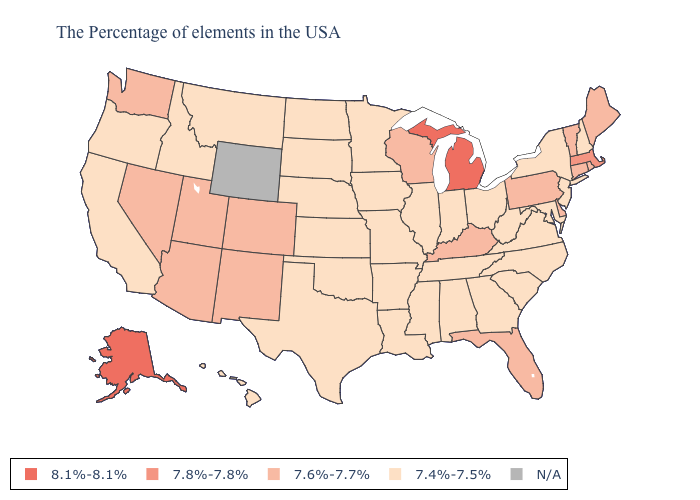Does Michigan have the highest value in the MidWest?
Give a very brief answer. Yes. What is the highest value in the USA?
Give a very brief answer. 8.1%-8.1%. Name the states that have a value in the range 8.1%-8.1%?
Concise answer only. Michigan, Alaska. Does California have the highest value in the USA?
Give a very brief answer. No. Name the states that have a value in the range 7.6%-7.7%?
Keep it brief. Maine, Rhode Island, Vermont, Connecticut, Delaware, Pennsylvania, Florida, Kentucky, Wisconsin, Colorado, New Mexico, Utah, Arizona, Nevada, Washington. Does the first symbol in the legend represent the smallest category?
Concise answer only. No. What is the lowest value in the West?
Concise answer only. 7.4%-7.5%. What is the lowest value in the USA?
Quick response, please. 7.4%-7.5%. Name the states that have a value in the range 7.4%-7.5%?
Concise answer only. New Hampshire, New York, New Jersey, Maryland, Virginia, North Carolina, South Carolina, West Virginia, Ohio, Georgia, Indiana, Alabama, Tennessee, Illinois, Mississippi, Louisiana, Missouri, Arkansas, Minnesota, Iowa, Kansas, Nebraska, Oklahoma, Texas, South Dakota, North Dakota, Montana, Idaho, California, Oregon, Hawaii. What is the value of Oregon?
Be succinct. 7.4%-7.5%. What is the highest value in the USA?
Keep it brief. 8.1%-8.1%. 